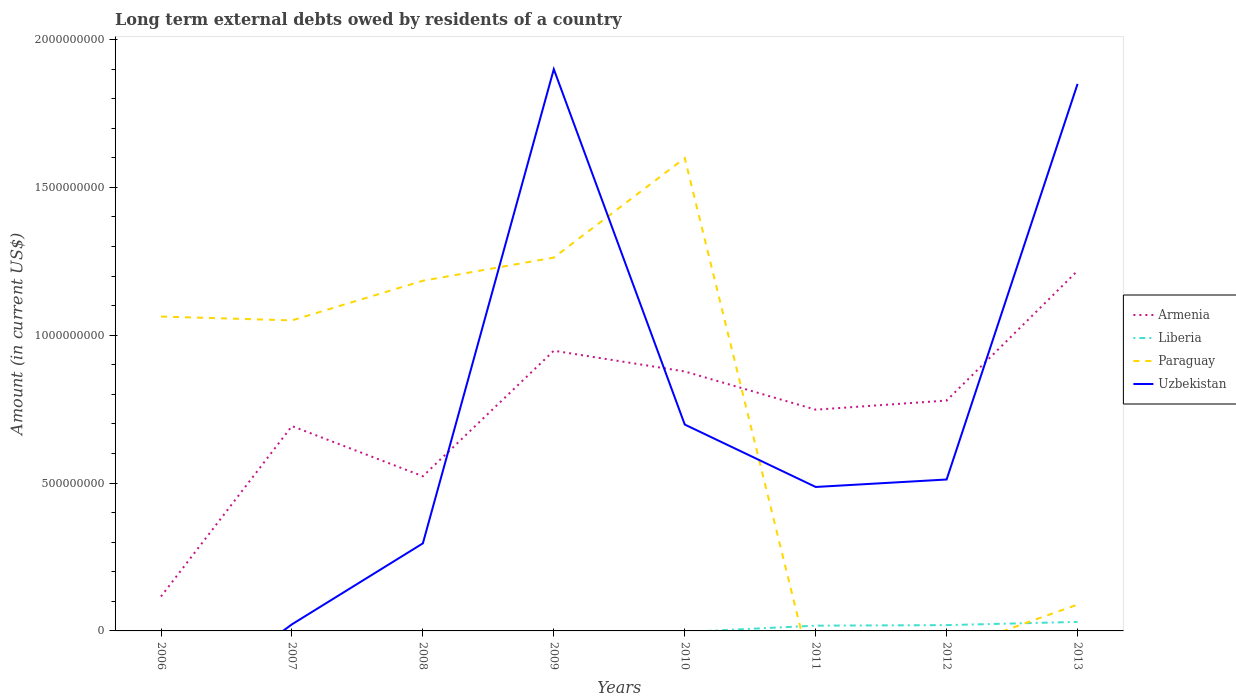How many different coloured lines are there?
Offer a very short reply. 4. Across all years, what is the maximum amount of long-term external debts owed by residents in Armenia?
Keep it short and to the point. 1.16e+08. What is the total amount of long-term external debts owed by residents in Armenia in the graph?
Keep it short and to the point. -6.95e+08. What is the difference between the highest and the second highest amount of long-term external debts owed by residents in Liberia?
Make the answer very short. 3.05e+07. Is the amount of long-term external debts owed by residents in Uzbekistan strictly greater than the amount of long-term external debts owed by residents in Liberia over the years?
Offer a terse response. No. How many years are there in the graph?
Your answer should be compact. 8. Does the graph contain any zero values?
Give a very brief answer. Yes. Does the graph contain grids?
Your answer should be compact. No. Where does the legend appear in the graph?
Provide a succinct answer. Center right. How are the legend labels stacked?
Ensure brevity in your answer.  Vertical. What is the title of the graph?
Provide a short and direct response. Long term external debts owed by residents of a country. Does "Bermuda" appear as one of the legend labels in the graph?
Ensure brevity in your answer.  No. What is the label or title of the X-axis?
Provide a short and direct response. Years. What is the label or title of the Y-axis?
Give a very brief answer. Amount (in current US$). What is the Amount (in current US$) in Armenia in 2006?
Make the answer very short. 1.16e+08. What is the Amount (in current US$) of Paraguay in 2006?
Keep it short and to the point. 1.06e+09. What is the Amount (in current US$) in Uzbekistan in 2006?
Your answer should be compact. 0. What is the Amount (in current US$) of Armenia in 2007?
Your answer should be compact. 6.93e+08. What is the Amount (in current US$) of Paraguay in 2007?
Your response must be concise. 1.05e+09. What is the Amount (in current US$) in Uzbekistan in 2007?
Your answer should be very brief. 2.23e+07. What is the Amount (in current US$) in Armenia in 2008?
Provide a short and direct response. 5.23e+08. What is the Amount (in current US$) of Liberia in 2008?
Give a very brief answer. 0. What is the Amount (in current US$) of Paraguay in 2008?
Your answer should be very brief. 1.18e+09. What is the Amount (in current US$) in Uzbekistan in 2008?
Keep it short and to the point. 2.96e+08. What is the Amount (in current US$) of Armenia in 2009?
Keep it short and to the point. 9.47e+08. What is the Amount (in current US$) in Liberia in 2009?
Your answer should be compact. 0. What is the Amount (in current US$) in Paraguay in 2009?
Provide a succinct answer. 1.26e+09. What is the Amount (in current US$) in Uzbekistan in 2009?
Provide a succinct answer. 1.90e+09. What is the Amount (in current US$) in Armenia in 2010?
Offer a terse response. 8.77e+08. What is the Amount (in current US$) in Paraguay in 2010?
Make the answer very short. 1.60e+09. What is the Amount (in current US$) of Uzbekistan in 2010?
Give a very brief answer. 6.98e+08. What is the Amount (in current US$) in Armenia in 2011?
Offer a very short reply. 7.48e+08. What is the Amount (in current US$) in Liberia in 2011?
Provide a short and direct response. 1.78e+07. What is the Amount (in current US$) in Paraguay in 2011?
Keep it short and to the point. 0. What is the Amount (in current US$) in Uzbekistan in 2011?
Provide a succinct answer. 4.87e+08. What is the Amount (in current US$) in Armenia in 2012?
Your answer should be very brief. 7.79e+08. What is the Amount (in current US$) of Liberia in 2012?
Ensure brevity in your answer.  1.96e+07. What is the Amount (in current US$) of Uzbekistan in 2012?
Offer a terse response. 5.12e+08. What is the Amount (in current US$) of Armenia in 2013?
Give a very brief answer. 1.22e+09. What is the Amount (in current US$) of Liberia in 2013?
Provide a succinct answer. 3.05e+07. What is the Amount (in current US$) of Paraguay in 2013?
Ensure brevity in your answer.  8.90e+07. What is the Amount (in current US$) of Uzbekistan in 2013?
Ensure brevity in your answer.  1.85e+09. Across all years, what is the maximum Amount (in current US$) of Armenia?
Provide a short and direct response. 1.22e+09. Across all years, what is the maximum Amount (in current US$) of Liberia?
Provide a succinct answer. 3.05e+07. Across all years, what is the maximum Amount (in current US$) of Paraguay?
Offer a terse response. 1.60e+09. Across all years, what is the maximum Amount (in current US$) of Uzbekistan?
Keep it short and to the point. 1.90e+09. Across all years, what is the minimum Amount (in current US$) in Armenia?
Provide a succinct answer. 1.16e+08. Across all years, what is the minimum Amount (in current US$) in Uzbekistan?
Offer a terse response. 0. What is the total Amount (in current US$) of Armenia in the graph?
Offer a terse response. 5.90e+09. What is the total Amount (in current US$) in Liberia in the graph?
Provide a short and direct response. 6.79e+07. What is the total Amount (in current US$) in Paraguay in the graph?
Keep it short and to the point. 6.25e+09. What is the total Amount (in current US$) in Uzbekistan in the graph?
Your response must be concise. 5.76e+09. What is the difference between the Amount (in current US$) of Armenia in 2006 and that in 2007?
Make the answer very short. -5.76e+08. What is the difference between the Amount (in current US$) in Paraguay in 2006 and that in 2007?
Your answer should be very brief. 1.30e+07. What is the difference between the Amount (in current US$) in Armenia in 2006 and that in 2008?
Give a very brief answer. -4.07e+08. What is the difference between the Amount (in current US$) in Paraguay in 2006 and that in 2008?
Offer a terse response. -1.21e+08. What is the difference between the Amount (in current US$) of Armenia in 2006 and that in 2009?
Offer a very short reply. -8.31e+08. What is the difference between the Amount (in current US$) of Paraguay in 2006 and that in 2009?
Make the answer very short. -1.99e+08. What is the difference between the Amount (in current US$) in Armenia in 2006 and that in 2010?
Ensure brevity in your answer.  -7.61e+08. What is the difference between the Amount (in current US$) in Paraguay in 2006 and that in 2010?
Offer a very short reply. -5.36e+08. What is the difference between the Amount (in current US$) in Armenia in 2006 and that in 2011?
Ensure brevity in your answer.  -6.32e+08. What is the difference between the Amount (in current US$) of Armenia in 2006 and that in 2012?
Your response must be concise. -6.63e+08. What is the difference between the Amount (in current US$) of Armenia in 2006 and that in 2013?
Provide a short and direct response. -1.10e+09. What is the difference between the Amount (in current US$) of Paraguay in 2006 and that in 2013?
Make the answer very short. 9.74e+08. What is the difference between the Amount (in current US$) of Armenia in 2007 and that in 2008?
Ensure brevity in your answer.  1.70e+08. What is the difference between the Amount (in current US$) of Paraguay in 2007 and that in 2008?
Your response must be concise. -1.34e+08. What is the difference between the Amount (in current US$) in Uzbekistan in 2007 and that in 2008?
Your answer should be compact. -2.74e+08. What is the difference between the Amount (in current US$) of Armenia in 2007 and that in 2009?
Your response must be concise. -2.55e+08. What is the difference between the Amount (in current US$) of Paraguay in 2007 and that in 2009?
Your answer should be compact. -2.12e+08. What is the difference between the Amount (in current US$) of Uzbekistan in 2007 and that in 2009?
Ensure brevity in your answer.  -1.88e+09. What is the difference between the Amount (in current US$) in Armenia in 2007 and that in 2010?
Your answer should be very brief. -1.85e+08. What is the difference between the Amount (in current US$) of Paraguay in 2007 and that in 2010?
Offer a terse response. -5.49e+08. What is the difference between the Amount (in current US$) of Uzbekistan in 2007 and that in 2010?
Ensure brevity in your answer.  -6.76e+08. What is the difference between the Amount (in current US$) of Armenia in 2007 and that in 2011?
Your response must be concise. -5.54e+07. What is the difference between the Amount (in current US$) in Uzbekistan in 2007 and that in 2011?
Your answer should be very brief. -4.64e+08. What is the difference between the Amount (in current US$) in Armenia in 2007 and that in 2012?
Give a very brief answer. -8.64e+07. What is the difference between the Amount (in current US$) of Uzbekistan in 2007 and that in 2012?
Offer a very short reply. -4.90e+08. What is the difference between the Amount (in current US$) of Armenia in 2007 and that in 2013?
Give a very brief answer. -5.25e+08. What is the difference between the Amount (in current US$) of Paraguay in 2007 and that in 2013?
Keep it short and to the point. 9.61e+08. What is the difference between the Amount (in current US$) in Uzbekistan in 2007 and that in 2013?
Your response must be concise. -1.83e+09. What is the difference between the Amount (in current US$) of Armenia in 2008 and that in 2009?
Your answer should be compact. -4.24e+08. What is the difference between the Amount (in current US$) of Paraguay in 2008 and that in 2009?
Give a very brief answer. -7.84e+07. What is the difference between the Amount (in current US$) of Uzbekistan in 2008 and that in 2009?
Give a very brief answer. -1.60e+09. What is the difference between the Amount (in current US$) of Armenia in 2008 and that in 2010?
Provide a short and direct response. -3.54e+08. What is the difference between the Amount (in current US$) in Paraguay in 2008 and that in 2010?
Your answer should be compact. -4.15e+08. What is the difference between the Amount (in current US$) in Uzbekistan in 2008 and that in 2010?
Keep it short and to the point. -4.02e+08. What is the difference between the Amount (in current US$) in Armenia in 2008 and that in 2011?
Provide a short and direct response. -2.25e+08. What is the difference between the Amount (in current US$) in Uzbekistan in 2008 and that in 2011?
Ensure brevity in your answer.  -1.91e+08. What is the difference between the Amount (in current US$) in Armenia in 2008 and that in 2012?
Offer a terse response. -2.56e+08. What is the difference between the Amount (in current US$) of Uzbekistan in 2008 and that in 2012?
Provide a short and direct response. -2.16e+08. What is the difference between the Amount (in current US$) of Armenia in 2008 and that in 2013?
Provide a short and direct response. -6.95e+08. What is the difference between the Amount (in current US$) of Paraguay in 2008 and that in 2013?
Provide a short and direct response. 1.10e+09. What is the difference between the Amount (in current US$) of Uzbekistan in 2008 and that in 2013?
Your answer should be compact. -1.55e+09. What is the difference between the Amount (in current US$) of Armenia in 2009 and that in 2010?
Give a very brief answer. 7.02e+07. What is the difference between the Amount (in current US$) in Paraguay in 2009 and that in 2010?
Your answer should be very brief. -3.36e+08. What is the difference between the Amount (in current US$) in Uzbekistan in 2009 and that in 2010?
Keep it short and to the point. 1.20e+09. What is the difference between the Amount (in current US$) of Armenia in 2009 and that in 2011?
Offer a very short reply. 1.99e+08. What is the difference between the Amount (in current US$) of Uzbekistan in 2009 and that in 2011?
Provide a short and direct response. 1.41e+09. What is the difference between the Amount (in current US$) of Armenia in 2009 and that in 2012?
Your answer should be very brief. 1.68e+08. What is the difference between the Amount (in current US$) in Uzbekistan in 2009 and that in 2012?
Make the answer very short. 1.39e+09. What is the difference between the Amount (in current US$) in Armenia in 2009 and that in 2013?
Ensure brevity in your answer.  -2.70e+08. What is the difference between the Amount (in current US$) of Paraguay in 2009 and that in 2013?
Provide a succinct answer. 1.17e+09. What is the difference between the Amount (in current US$) in Uzbekistan in 2009 and that in 2013?
Your answer should be very brief. 4.99e+07. What is the difference between the Amount (in current US$) in Armenia in 2010 and that in 2011?
Make the answer very short. 1.29e+08. What is the difference between the Amount (in current US$) of Uzbekistan in 2010 and that in 2011?
Your answer should be very brief. 2.11e+08. What is the difference between the Amount (in current US$) in Armenia in 2010 and that in 2012?
Make the answer very short. 9.83e+07. What is the difference between the Amount (in current US$) in Uzbekistan in 2010 and that in 2012?
Your response must be concise. 1.86e+08. What is the difference between the Amount (in current US$) of Armenia in 2010 and that in 2013?
Offer a very short reply. -3.40e+08. What is the difference between the Amount (in current US$) of Paraguay in 2010 and that in 2013?
Make the answer very short. 1.51e+09. What is the difference between the Amount (in current US$) of Uzbekistan in 2010 and that in 2013?
Ensure brevity in your answer.  -1.15e+09. What is the difference between the Amount (in current US$) of Armenia in 2011 and that in 2012?
Your answer should be very brief. -3.09e+07. What is the difference between the Amount (in current US$) in Liberia in 2011 and that in 2012?
Provide a short and direct response. -1.84e+06. What is the difference between the Amount (in current US$) of Uzbekistan in 2011 and that in 2012?
Your response must be concise. -2.52e+07. What is the difference between the Amount (in current US$) in Armenia in 2011 and that in 2013?
Offer a terse response. -4.70e+08. What is the difference between the Amount (in current US$) in Liberia in 2011 and that in 2013?
Provide a short and direct response. -1.27e+07. What is the difference between the Amount (in current US$) in Uzbekistan in 2011 and that in 2013?
Offer a very short reply. -1.36e+09. What is the difference between the Amount (in current US$) in Armenia in 2012 and that in 2013?
Ensure brevity in your answer.  -4.39e+08. What is the difference between the Amount (in current US$) in Liberia in 2012 and that in 2013?
Your answer should be compact. -1.09e+07. What is the difference between the Amount (in current US$) of Uzbekistan in 2012 and that in 2013?
Keep it short and to the point. -1.34e+09. What is the difference between the Amount (in current US$) of Armenia in 2006 and the Amount (in current US$) of Paraguay in 2007?
Make the answer very short. -9.34e+08. What is the difference between the Amount (in current US$) in Armenia in 2006 and the Amount (in current US$) in Uzbekistan in 2007?
Provide a short and direct response. 9.42e+07. What is the difference between the Amount (in current US$) in Paraguay in 2006 and the Amount (in current US$) in Uzbekistan in 2007?
Provide a short and direct response. 1.04e+09. What is the difference between the Amount (in current US$) in Armenia in 2006 and the Amount (in current US$) in Paraguay in 2008?
Provide a short and direct response. -1.07e+09. What is the difference between the Amount (in current US$) in Armenia in 2006 and the Amount (in current US$) in Uzbekistan in 2008?
Ensure brevity in your answer.  -1.80e+08. What is the difference between the Amount (in current US$) of Paraguay in 2006 and the Amount (in current US$) of Uzbekistan in 2008?
Ensure brevity in your answer.  7.67e+08. What is the difference between the Amount (in current US$) of Armenia in 2006 and the Amount (in current US$) of Paraguay in 2009?
Provide a short and direct response. -1.15e+09. What is the difference between the Amount (in current US$) of Armenia in 2006 and the Amount (in current US$) of Uzbekistan in 2009?
Give a very brief answer. -1.78e+09. What is the difference between the Amount (in current US$) in Paraguay in 2006 and the Amount (in current US$) in Uzbekistan in 2009?
Offer a terse response. -8.36e+08. What is the difference between the Amount (in current US$) of Armenia in 2006 and the Amount (in current US$) of Paraguay in 2010?
Provide a succinct answer. -1.48e+09. What is the difference between the Amount (in current US$) of Armenia in 2006 and the Amount (in current US$) of Uzbekistan in 2010?
Provide a short and direct response. -5.81e+08. What is the difference between the Amount (in current US$) of Paraguay in 2006 and the Amount (in current US$) of Uzbekistan in 2010?
Provide a short and direct response. 3.65e+08. What is the difference between the Amount (in current US$) in Armenia in 2006 and the Amount (in current US$) in Liberia in 2011?
Provide a short and direct response. 9.87e+07. What is the difference between the Amount (in current US$) in Armenia in 2006 and the Amount (in current US$) in Uzbekistan in 2011?
Give a very brief answer. -3.70e+08. What is the difference between the Amount (in current US$) of Paraguay in 2006 and the Amount (in current US$) of Uzbekistan in 2011?
Offer a very short reply. 5.76e+08. What is the difference between the Amount (in current US$) in Armenia in 2006 and the Amount (in current US$) in Liberia in 2012?
Your response must be concise. 9.68e+07. What is the difference between the Amount (in current US$) in Armenia in 2006 and the Amount (in current US$) in Uzbekistan in 2012?
Provide a succinct answer. -3.96e+08. What is the difference between the Amount (in current US$) of Paraguay in 2006 and the Amount (in current US$) of Uzbekistan in 2012?
Ensure brevity in your answer.  5.51e+08. What is the difference between the Amount (in current US$) in Armenia in 2006 and the Amount (in current US$) in Liberia in 2013?
Provide a short and direct response. 8.60e+07. What is the difference between the Amount (in current US$) of Armenia in 2006 and the Amount (in current US$) of Paraguay in 2013?
Keep it short and to the point. 2.74e+07. What is the difference between the Amount (in current US$) in Armenia in 2006 and the Amount (in current US$) in Uzbekistan in 2013?
Offer a terse response. -1.73e+09. What is the difference between the Amount (in current US$) in Paraguay in 2006 and the Amount (in current US$) in Uzbekistan in 2013?
Provide a succinct answer. -7.87e+08. What is the difference between the Amount (in current US$) of Armenia in 2007 and the Amount (in current US$) of Paraguay in 2008?
Your answer should be very brief. -4.91e+08. What is the difference between the Amount (in current US$) in Armenia in 2007 and the Amount (in current US$) in Uzbekistan in 2008?
Your answer should be compact. 3.97e+08. What is the difference between the Amount (in current US$) of Paraguay in 2007 and the Amount (in current US$) of Uzbekistan in 2008?
Provide a short and direct response. 7.54e+08. What is the difference between the Amount (in current US$) of Armenia in 2007 and the Amount (in current US$) of Paraguay in 2009?
Your answer should be very brief. -5.70e+08. What is the difference between the Amount (in current US$) of Armenia in 2007 and the Amount (in current US$) of Uzbekistan in 2009?
Your answer should be compact. -1.21e+09. What is the difference between the Amount (in current US$) in Paraguay in 2007 and the Amount (in current US$) in Uzbekistan in 2009?
Make the answer very short. -8.50e+08. What is the difference between the Amount (in current US$) of Armenia in 2007 and the Amount (in current US$) of Paraguay in 2010?
Offer a very short reply. -9.06e+08. What is the difference between the Amount (in current US$) of Armenia in 2007 and the Amount (in current US$) of Uzbekistan in 2010?
Offer a very short reply. -5.17e+06. What is the difference between the Amount (in current US$) in Paraguay in 2007 and the Amount (in current US$) in Uzbekistan in 2010?
Offer a very short reply. 3.52e+08. What is the difference between the Amount (in current US$) in Armenia in 2007 and the Amount (in current US$) in Liberia in 2011?
Provide a succinct answer. 6.75e+08. What is the difference between the Amount (in current US$) in Armenia in 2007 and the Amount (in current US$) in Uzbekistan in 2011?
Make the answer very short. 2.06e+08. What is the difference between the Amount (in current US$) of Paraguay in 2007 and the Amount (in current US$) of Uzbekistan in 2011?
Provide a succinct answer. 5.63e+08. What is the difference between the Amount (in current US$) of Armenia in 2007 and the Amount (in current US$) of Liberia in 2012?
Your response must be concise. 6.73e+08. What is the difference between the Amount (in current US$) in Armenia in 2007 and the Amount (in current US$) in Uzbekistan in 2012?
Offer a terse response. 1.81e+08. What is the difference between the Amount (in current US$) of Paraguay in 2007 and the Amount (in current US$) of Uzbekistan in 2012?
Ensure brevity in your answer.  5.38e+08. What is the difference between the Amount (in current US$) of Armenia in 2007 and the Amount (in current US$) of Liberia in 2013?
Provide a succinct answer. 6.62e+08. What is the difference between the Amount (in current US$) of Armenia in 2007 and the Amount (in current US$) of Paraguay in 2013?
Your response must be concise. 6.04e+08. What is the difference between the Amount (in current US$) in Armenia in 2007 and the Amount (in current US$) in Uzbekistan in 2013?
Ensure brevity in your answer.  -1.16e+09. What is the difference between the Amount (in current US$) in Paraguay in 2007 and the Amount (in current US$) in Uzbekistan in 2013?
Offer a very short reply. -8.00e+08. What is the difference between the Amount (in current US$) in Armenia in 2008 and the Amount (in current US$) in Paraguay in 2009?
Your response must be concise. -7.39e+08. What is the difference between the Amount (in current US$) of Armenia in 2008 and the Amount (in current US$) of Uzbekistan in 2009?
Provide a short and direct response. -1.38e+09. What is the difference between the Amount (in current US$) of Paraguay in 2008 and the Amount (in current US$) of Uzbekistan in 2009?
Offer a terse response. -7.15e+08. What is the difference between the Amount (in current US$) in Armenia in 2008 and the Amount (in current US$) in Paraguay in 2010?
Your answer should be very brief. -1.08e+09. What is the difference between the Amount (in current US$) in Armenia in 2008 and the Amount (in current US$) in Uzbekistan in 2010?
Keep it short and to the point. -1.75e+08. What is the difference between the Amount (in current US$) in Paraguay in 2008 and the Amount (in current US$) in Uzbekistan in 2010?
Keep it short and to the point. 4.86e+08. What is the difference between the Amount (in current US$) of Armenia in 2008 and the Amount (in current US$) of Liberia in 2011?
Your response must be concise. 5.05e+08. What is the difference between the Amount (in current US$) in Armenia in 2008 and the Amount (in current US$) in Uzbekistan in 2011?
Ensure brevity in your answer.  3.63e+07. What is the difference between the Amount (in current US$) of Paraguay in 2008 and the Amount (in current US$) of Uzbekistan in 2011?
Provide a short and direct response. 6.97e+08. What is the difference between the Amount (in current US$) of Armenia in 2008 and the Amount (in current US$) of Liberia in 2012?
Provide a succinct answer. 5.03e+08. What is the difference between the Amount (in current US$) in Armenia in 2008 and the Amount (in current US$) in Uzbekistan in 2012?
Keep it short and to the point. 1.10e+07. What is the difference between the Amount (in current US$) of Paraguay in 2008 and the Amount (in current US$) of Uzbekistan in 2012?
Provide a succinct answer. 6.72e+08. What is the difference between the Amount (in current US$) of Armenia in 2008 and the Amount (in current US$) of Liberia in 2013?
Offer a terse response. 4.93e+08. What is the difference between the Amount (in current US$) in Armenia in 2008 and the Amount (in current US$) in Paraguay in 2013?
Your answer should be compact. 4.34e+08. What is the difference between the Amount (in current US$) in Armenia in 2008 and the Amount (in current US$) in Uzbekistan in 2013?
Keep it short and to the point. -1.33e+09. What is the difference between the Amount (in current US$) of Paraguay in 2008 and the Amount (in current US$) of Uzbekistan in 2013?
Provide a short and direct response. -6.66e+08. What is the difference between the Amount (in current US$) in Armenia in 2009 and the Amount (in current US$) in Paraguay in 2010?
Offer a very short reply. -6.51e+08. What is the difference between the Amount (in current US$) of Armenia in 2009 and the Amount (in current US$) of Uzbekistan in 2010?
Provide a short and direct response. 2.50e+08. What is the difference between the Amount (in current US$) of Paraguay in 2009 and the Amount (in current US$) of Uzbekistan in 2010?
Your answer should be very brief. 5.65e+08. What is the difference between the Amount (in current US$) of Armenia in 2009 and the Amount (in current US$) of Liberia in 2011?
Your response must be concise. 9.30e+08. What is the difference between the Amount (in current US$) in Armenia in 2009 and the Amount (in current US$) in Uzbekistan in 2011?
Your answer should be very brief. 4.61e+08. What is the difference between the Amount (in current US$) of Paraguay in 2009 and the Amount (in current US$) of Uzbekistan in 2011?
Offer a terse response. 7.76e+08. What is the difference between the Amount (in current US$) of Armenia in 2009 and the Amount (in current US$) of Liberia in 2012?
Make the answer very short. 9.28e+08. What is the difference between the Amount (in current US$) in Armenia in 2009 and the Amount (in current US$) in Uzbekistan in 2012?
Provide a succinct answer. 4.35e+08. What is the difference between the Amount (in current US$) of Paraguay in 2009 and the Amount (in current US$) of Uzbekistan in 2012?
Offer a terse response. 7.50e+08. What is the difference between the Amount (in current US$) of Armenia in 2009 and the Amount (in current US$) of Liberia in 2013?
Keep it short and to the point. 9.17e+08. What is the difference between the Amount (in current US$) of Armenia in 2009 and the Amount (in current US$) of Paraguay in 2013?
Your answer should be very brief. 8.58e+08. What is the difference between the Amount (in current US$) of Armenia in 2009 and the Amount (in current US$) of Uzbekistan in 2013?
Keep it short and to the point. -9.02e+08. What is the difference between the Amount (in current US$) in Paraguay in 2009 and the Amount (in current US$) in Uzbekistan in 2013?
Provide a succinct answer. -5.87e+08. What is the difference between the Amount (in current US$) of Armenia in 2010 and the Amount (in current US$) of Liberia in 2011?
Offer a terse response. 8.60e+08. What is the difference between the Amount (in current US$) of Armenia in 2010 and the Amount (in current US$) of Uzbekistan in 2011?
Your answer should be compact. 3.91e+08. What is the difference between the Amount (in current US$) of Paraguay in 2010 and the Amount (in current US$) of Uzbekistan in 2011?
Offer a terse response. 1.11e+09. What is the difference between the Amount (in current US$) of Armenia in 2010 and the Amount (in current US$) of Liberia in 2012?
Your answer should be compact. 8.58e+08. What is the difference between the Amount (in current US$) in Armenia in 2010 and the Amount (in current US$) in Uzbekistan in 2012?
Make the answer very short. 3.65e+08. What is the difference between the Amount (in current US$) in Paraguay in 2010 and the Amount (in current US$) in Uzbekistan in 2012?
Your answer should be compact. 1.09e+09. What is the difference between the Amount (in current US$) in Armenia in 2010 and the Amount (in current US$) in Liberia in 2013?
Your answer should be compact. 8.47e+08. What is the difference between the Amount (in current US$) of Armenia in 2010 and the Amount (in current US$) of Paraguay in 2013?
Ensure brevity in your answer.  7.88e+08. What is the difference between the Amount (in current US$) in Armenia in 2010 and the Amount (in current US$) in Uzbekistan in 2013?
Your answer should be compact. -9.72e+08. What is the difference between the Amount (in current US$) in Paraguay in 2010 and the Amount (in current US$) in Uzbekistan in 2013?
Offer a terse response. -2.51e+08. What is the difference between the Amount (in current US$) in Armenia in 2011 and the Amount (in current US$) in Liberia in 2012?
Ensure brevity in your answer.  7.28e+08. What is the difference between the Amount (in current US$) of Armenia in 2011 and the Amount (in current US$) of Uzbekistan in 2012?
Make the answer very short. 2.36e+08. What is the difference between the Amount (in current US$) of Liberia in 2011 and the Amount (in current US$) of Uzbekistan in 2012?
Give a very brief answer. -4.94e+08. What is the difference between the Amount (in current US$) in Armenia in 2011 and the Amount (in current US$) in Liberia in 2013?
Offer a terse response. 7.18e+08. What is the difference between the Amount (in current US$) in Armenia in 2011 and the Amount (in current US$) in Paraguay in 2013?
Give a very brief answer. 6.59e+08. What is the difference between the Amount (in current US$) of Armenia in 2011 and the Amount (in current US$) of Uzbekistan in 2013?
Offer a terse response. -1.10e+09. What is the difference between the Amount (in current US$) of Liberia in 2011 and the Amount (in current US$) of Paraguay in 2013?
Your answer should be compact. -7.12e+07. What is the difference between the Amount (in current US$) of Liberia in 2011 and the Amount (in current US$) of Uzbekistan in 2013?
Ensure brevity in your answer.  -1.83e+09. What is the difference between the Amount (in current US$) of Armenia in 2012 and the Amount (in current US$) of Liberia in 2013?
Your response must be concise. 7.49e+08. What is the difference between the Amount (in current US$) in Armenia in 2012 and the Amount (in current US$) in Paraguay in 2013?
Make the answer very short. 6.90e+08. What is the difference between the Amount (in current US$) of Armenia in 2012 and the Amount (in current US$) of Uzbekistan in 2013?
Provide a succinct answer. -1.07e+09. What is the difference between the Amount (in current US$) of Liberia in 2012 and the Amount (in current US$) of Paraguay in 2013?
Offer a terse response. -6.94e+07. What is the difference between the Amount (in current US$) in Liberia in 2012 and the Amount (in current US$) in Uzbekistan in 2013?
Offer a terse response. -1.83e+09. What is the average Amount (in current US$) in Armenia per year?
Provide a succinct answer. 7.38e+08. What is the average Amount (in current US$) of Liberia per year?
Offer a terse response. 8.49e+06. What is the average Amount (in current US$) in Paraguay per year?
Your answer should be very brief. 7.81e+08. What is the average Amount (in current US$) of Uzbekistan per year?
Give a very brief answer. 7.21e+08. In the year 2006, what is the difference between the Amount (in current US$) in Armenia and Amount (in current US$) in Paraguay?
Your answer should be very brief. -9.47e+08. In the year 2007, what is the difference between the Amount (in current US$) in Armenia and Amount (in current US$) in Paraguay?
Keep it short and to the point. -3.57e+08. In the year 2007, what is the difference between the Amount (in current US$) in Armenia and Amount (in current US$) in Uzbekistan?
Provide a short and direct response. 6.70e+08. In the year 2007, what is the difference between the Amount (in current US$) of Paraguay and Amount (in current US$) of Uzbekistan?
Make the answer very short. 1.03e+09. In the year 2008, what is the difference between the Amount (in current US$) in Armenia and Amount (in current US$) in Paraguay?
Give a very brief answer. -6.61e+08. In the year 2008, what is the difference between the Amount (in current US$) in Armenia and Amount (in current US$) in Uzbekistan?
Your answer should be very brief. 2.27e+08. In the year 2008, what is the difference between the Amount (in current US$) in Paraguay and Amount (in current US$) in Uzbekistan?
Make the answer very short. 8.88e+08. In the year 2009, what is the difference between the Amount (in current US$) in Armenia and Amount (in current US$) in Paraguay?
Provide a succinct answer. -3.15e+08. In the year 2009, what is the difference between the Amount (in current US$) in Armenia and Amount (in current US$) in Uzbekistan?
Keep it short and to the point. -9.52e+08. In the year 2009, what is the difference between the Amount (in current US$) of Paraguay and Amount (in current US$) of Uzbekistan?
Your answer should be compact. -6.37e+08. In the year 2010, what is the difference between the Amount (in current US$) of Armenia and Amount (in current US$) of Paraguay?
Offer a very short reply. -7.22e+08. In the year 2010, what is the difference between the Amount (in current US$) in Armenia and Amount (in current US$) in Uzbekistan?
Your response must be concise. 1.79e+08. In the year 2010, what is the difference between the Amount (in current US$) of Paraguay and Amount (in current US$) of Uzbekistan?
Make the answer very short. 9.01e+08. In the year 2011, what is the difference between the Amount (in current US$) in Armenia and Amount (in current US$) in Liberia?
Your answer should be very brief. 7.30e+08. In the year 2011, what is the difference between the Amount (in current US$) in Armenia and Amount (in current US$) in Uzbekistan?
Your answer should be very brief. 2.61e+08. In the year 2011, what is the difference between the Amount (in current US$) in Liberia and Amount (in current US$) in Uzbekistan?
Ensure brevity in your answer.  -4.69e+08. In the year 2012, what is the difference between the Amount (in current US$) of Armenia and Amount (in current US$) of Liberia?
Keep it short and to the point. 7.59e+08. In the year 2012, what is the difference between the Amount (in current US$) of Armenia and Amount (in current US$) of Uzbekistan?
Offer a very short reply. 2.67e+08. In the year 2012, what is the difference between the Amount (in current US$) in Liberia and Amount (in current US$) in Uzbekistan?
Your response must be concise. -4.92e+08. In the year 2013, what is the difference between the Amount (in current US$) of Armenia and Amount (in current US$) of Liberia?
Provide a succinct answer. 1.19e+09. In the year 2013, what is the difference between the Amount (in current US$) in Armenia and Amount (in current US$) in Paraguay?
Offer a terse response. 1.13e+09. In the year 2013, what is the difference between the Amount (in current US$) of Armenia and Amount (in current US$) of Uzbekistan?
Provide a short and direct response. -6.32e+08. In the year 2013, what is the difference between the Amount (in current US$) of Liberia and Amount (in current US$) of Paraguay?
Make the answer very short. -5.85e+07. In the year 2013, what is the difference between the Amount (in current US$) in Liberia and Amount (in current US$) in Uzbekistan?
Provide a short and direct response. -1.82e+09. In the year 2013, what is the difference between the Amount (in current US$) in Paraguay and Amount (in current US$) in Uzbekistan?
Keep it short and to the point. -1.76e+09. What is the ratio of the Amount (in current US$) in Armenia in 2006 to that in 2007?
Keep it short and to the point. 0.17. What is the ratio of the Amount (in current US$) of Paraguay in 2006 to that in 2007?
Your answer should be compact. 1.01. What is the ratio of the Amount (in current US$) in Armenia in 2006 to that in 2008?
Make the answer very short. 0.22. What is the ratio of the Amount (in current US$) of Paraguay in 2006 to that in 2008?
Provide a short and direct response. 0.9. What is the ratio of the Amount (in current US$) of Armenia in 2006 to that in 2009?
Keep it short and to the point. 0.12. What is the ratio of the Amount (in current US$) of Paraguay in 2006 to that in 2009?
Your answer should be very brief. 0.84. What is the ratio of the Amount (in current US$) of Armenia in 2006 to that in 2010?
Provide a short and direct response. 0.13. What is the ratio of the Amount (in current US$) in Paraguay in 2006 to that in 2010?
Your response must be concise. 0.66. What is the ratio of the Amount (in current US$) of Armenia in 2006 to that in 2011?
Your answer should be very brief. 0.16. What is the ratio of the Amount (in current US$) in Armenia in 2006 to that in 2012?
Your response must be concise. 0.15. What is the ratio of the Amount (in current US$) of Armenia in 2006 to that in 2013?
Keep it short and to the point. 0.1. What is the ratio of the Amount (in current US$) of Paraguay in 2006 to that in 2013?
Your answer should be compact. 11.94. What is the ratio of the Amount (in current US$) in Armenia in 2007 to that in 2008?
Offer a terse response. 1.32. What is the ratio of the Amount (in current US$) in Paraguay in 2007 to that in 2008?
Offer a terse response. 0.89. What is the ratio of the Amount (in current US$) of Uzbekistan in 2007 to that in 2008?
Provide a short and direct response. 0.08. What is the ratio of the Amount (in current US$) of Armenia in 2007 to that in 2009?
Provide a succinct answer. 0.73. What is the ratio of the Amount (in current US$) of Paraguay in 2007 to that in 2009?
Keep it short and to the point. 0.83. What is the ratio of the Amount (in current US$) in Uzbekistan in 2007 to that in 2009?
Your answer should be compact. 0.01. What is the ratio of the Amount (in current US$) of Armenia in 2007 to that in 2010?
Ensure brevity in your answer.  0.79. What is the ratio of the Amount (in current US$) in Paraguay in 2007 to that in 2010?
Your answer should be compact. 0.66. What is the ratio of the Amount (in current US$) of Uzbekistan in 2007 to that in 2010?
Make the answer very short. 0.03. What is the ratio of the Amount (in current US$) of Armenia in 2007 to that in 2011?
Offer a terse response. 0.93. What is the ratio of the Amount (in current US$) in Uzbekistan in 2007 to that in 2011?
Offer a terse response. 0.05. What is the ratio of the Amount (in current US$) of Armenia in 2007 to that in 2012?
Your response must be concise. 0.89. What is the ratio of the Amount (in current US$) of Uzbekistan in 2007 to that in 2012?
Provide a succinct answer. 0.04. What is the ratio of the Amount (in current US$) in Armenia in 2007 to that in 2013?
Your response must be concise. 0.57. What is the ratio of the Amount (in current US$) of Paraguay in 2007 to that in 2013?
Provide a succinct answer. 11.79. What is the ratio of the Amount (in current US$) of Uzbekistan in 2007 to that in 2013?
Your response must be concise. 0.01. What is the ratio of the Amount (in current US$) in Armenia in 2008 to that in 2009?
Ensure brevity in your answer.  0.55. What is the ratio of the Amount (in current US$) of Paraguay in 2008 to that in 2009?
Give a very brief answer. 0.94. What is the ratio of the Amount (in current US$) in Uzbekistan in 2008 to that in 2009?
Offer a terse response. 0.16. What is the ratio of the Amount (in current US$) of Armenia in 2008 to that in 2010?
Your response must be concise. 0.6. What is the ratio of the Amount (in current US$) in Paraguay in 2008 to that in 2010?
Your answer should be compact. 0.74. What is the ratio of the Amount (in current US$) in Uzbekistan in 2008 to that in 2010?
Ensure brevity in your answer.  0.42. What is the ratio of the Amount (in current US$) in Armenia in 2008 to that in 2011?
Offer a very short reply. 0.7. What is the ratio of the Amount (in current US$) in Uzbekistan in 2008 to that in 2011?
Provide a short and direct response. 0.61. What is the ratio of the Amount (in current US$) in Armenia in 2008 to that in 2012?
Your answer should be very brief. 0.67. What is the ratio of the Amount (in current US$) of Uzbekistan in 2008 to that in 2012?
Provide a short and direct response. 0.58. What is the ratio of the Amount (in current US$) in Armenia in 2008 to that in 2013?
Make the answer very short. 0.43. What is the ratio of the Amount (in current US$) in Paraguay in 2008 to that in 2013?
Your answer should be very brief. 13.3. What is the ratio of the Amount (in current US$) of Uzbekistan in 2008 to that in 2013?
Ensure brevity in your answer.  0.16. What is the ratio of the Amount (in current US$) of Paraguay in 2009 to that in 2010?
Ensure brevity in your answer.  0.79. What is the ratio of the Amount (in current US$) in Uzbekistan in 2009 to that in 2010?
Provide a short and direct response. 2.72. What is the ratio of the Amount (in current US$) of Armenia in 2009 to that in 2011?
Your response must be concise. 1.27. What is the ratio of the Amount (in current US$) in Uzbekistan in 2009 to that in 2011?
Keep it short and to the point. 3.9. What is the ratio of the Amount (in current US$) in Armenia in 2009 to that in 2012?
Offer a very short reply. 1.22. What is the ratio of the Amount (in current US$) of Uzbekistan in 2009 to that in 2012?
Provide a short and direct response. 3.71. What is the ratio of the Amount (in current US$) of Armenia in 2009 to that in 2013?
Give a very brief answer. 0.78. What is the ratio of the Amount (in current US$) of Paraguay in 2009 to that in 2013?
Offer a very short reply. 14.18. What is the ratio of the Amount (in current US$) of Uzbekistan in 2009 to that in 2013?
Your response must be concise. 1.03. What is the ratio of the Amount (in current US$) of Armenia in 2010 to that in 2011?
Your answer should be compact. 1.17. What is the ratio of the Amount (in current US$) in Uzbekistan in 2010 to that in 2011?
Ensure brevity in your answer.  1.43. What is the ratio of the Amount (in current US$) of Armenia in 2010 to that in 2012?
Provide a short and direct response. 1.13. What is the ratio of the Amount (in current US$) of Uzbekistan in 2010 to that in 2012?
Provide a succinct answer. 1.36. What is the ratio of the Amount (in current US$) of Armenia in 2010 to that in 2013?
Offer a very short reply. 0.72. What is the ratio of the Amount (in current US$) in Paraguay in 2010 to that in 2013?
Keep it short and to the point. 17.96. What is the ratio of the Amount (in current US$) in Uzbekistan in 2010 to that in 2013?
Offer a very short reply. 0.38. What is the ratio of the Amount (in current US$) in Armenia in 2011 to that in 2012?
Offer a very short reply. 0.96. What is the ratio of the Amount (in current US$) in Liberia in 2011 to that in 2012?
Keep it short and to the point. 0.91. What is the ratio of the Amount (in current US$) in Uzbekistan in 2011 to that in 2012?
Offer a very short reply. 0.95. What is the ratio of the Amount (in current US$) of Armenia in 2011 to that in 2013?
Give a very brief answer. 0.61. What is the ratio of the Amount (in current US$) of Liberia in 2011 to that in 2013?
Provide a succinct answer. 0.58. What is the ratio of the Amount (in current US$) of Uzbekistan in 2011 to that in 2013?
Your answer should be compact. 0.26. What is the ratio of the Amount (in current US$) in Armenia in 2012 to that in 2013?
Your answer should be compact. 0.64. What is the ratio of the Amount (in current US$) of Liberia in 2012 to that in 2013?
Offer a terse response. 0.64. What is the ratio of the Amount (in current US$) of Uzbekistan in 2012 to that in 2013?
Your answer should be compact. 0.28. What is the difference between the highest and the second highest Amount (in current US$) in Armenia?
Provide a succinct answer. 2.70e+08. What is the difference between the highest and the second highest Amount (in current US$) in Liberia?
Keep it short and to the point. 1.09e+07. What is the difference between the highest and the second highest Amount (in current US$) in Paraguay?
Offer a terse response. 3.36e+08. What is the difference between the highest and the second highest Amount (in current US$) of Uzbekistan?
Keep it short and to the point. 4.99e+07. What is the difference between the highest and the lowest Amount (in current US$) of Armenia?
Ensure brevity in your answer.  1.10e+09. What is the difference between the highest and the lowest Amount (in current US$) of Liberia?
Your answer should be compact. 3.05e+07. What is the difference between the highest and the lowest Amount (in current US$) in Paraguay?
Offer a terse response. 1.60e+09. What is the difference between the highest and the lowest Amount (in current US$) of Uzbekistan?
Offer a very short reply. 1.90e+09. 